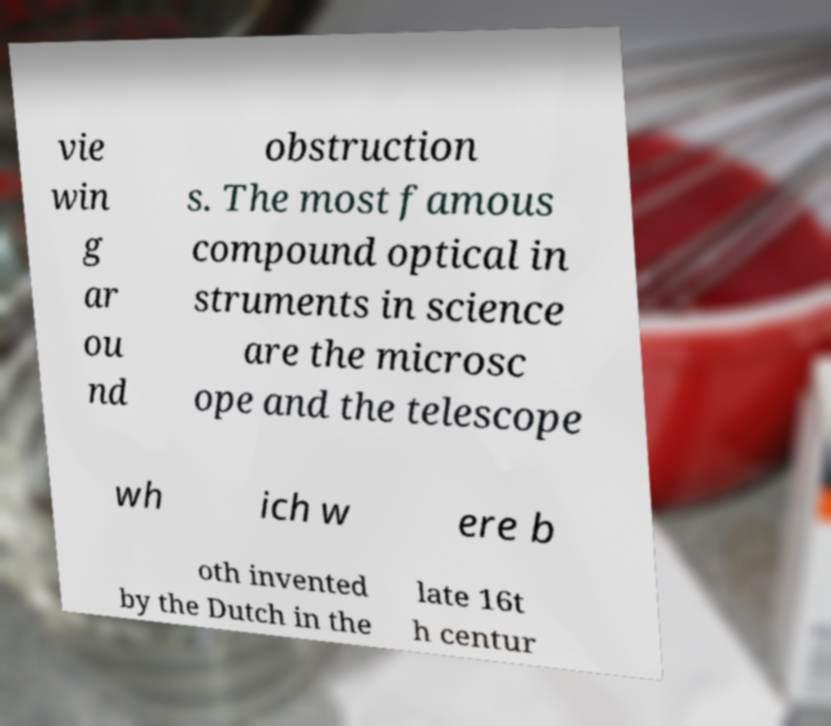Please identify and transcribe the text found in this image. vie win g ar ou nd obstruction s. The most famous compound optical in struments in science are the microsc ope and the telescope wh ich w ere b oth invented by the Dutch in the late 16t h centur 